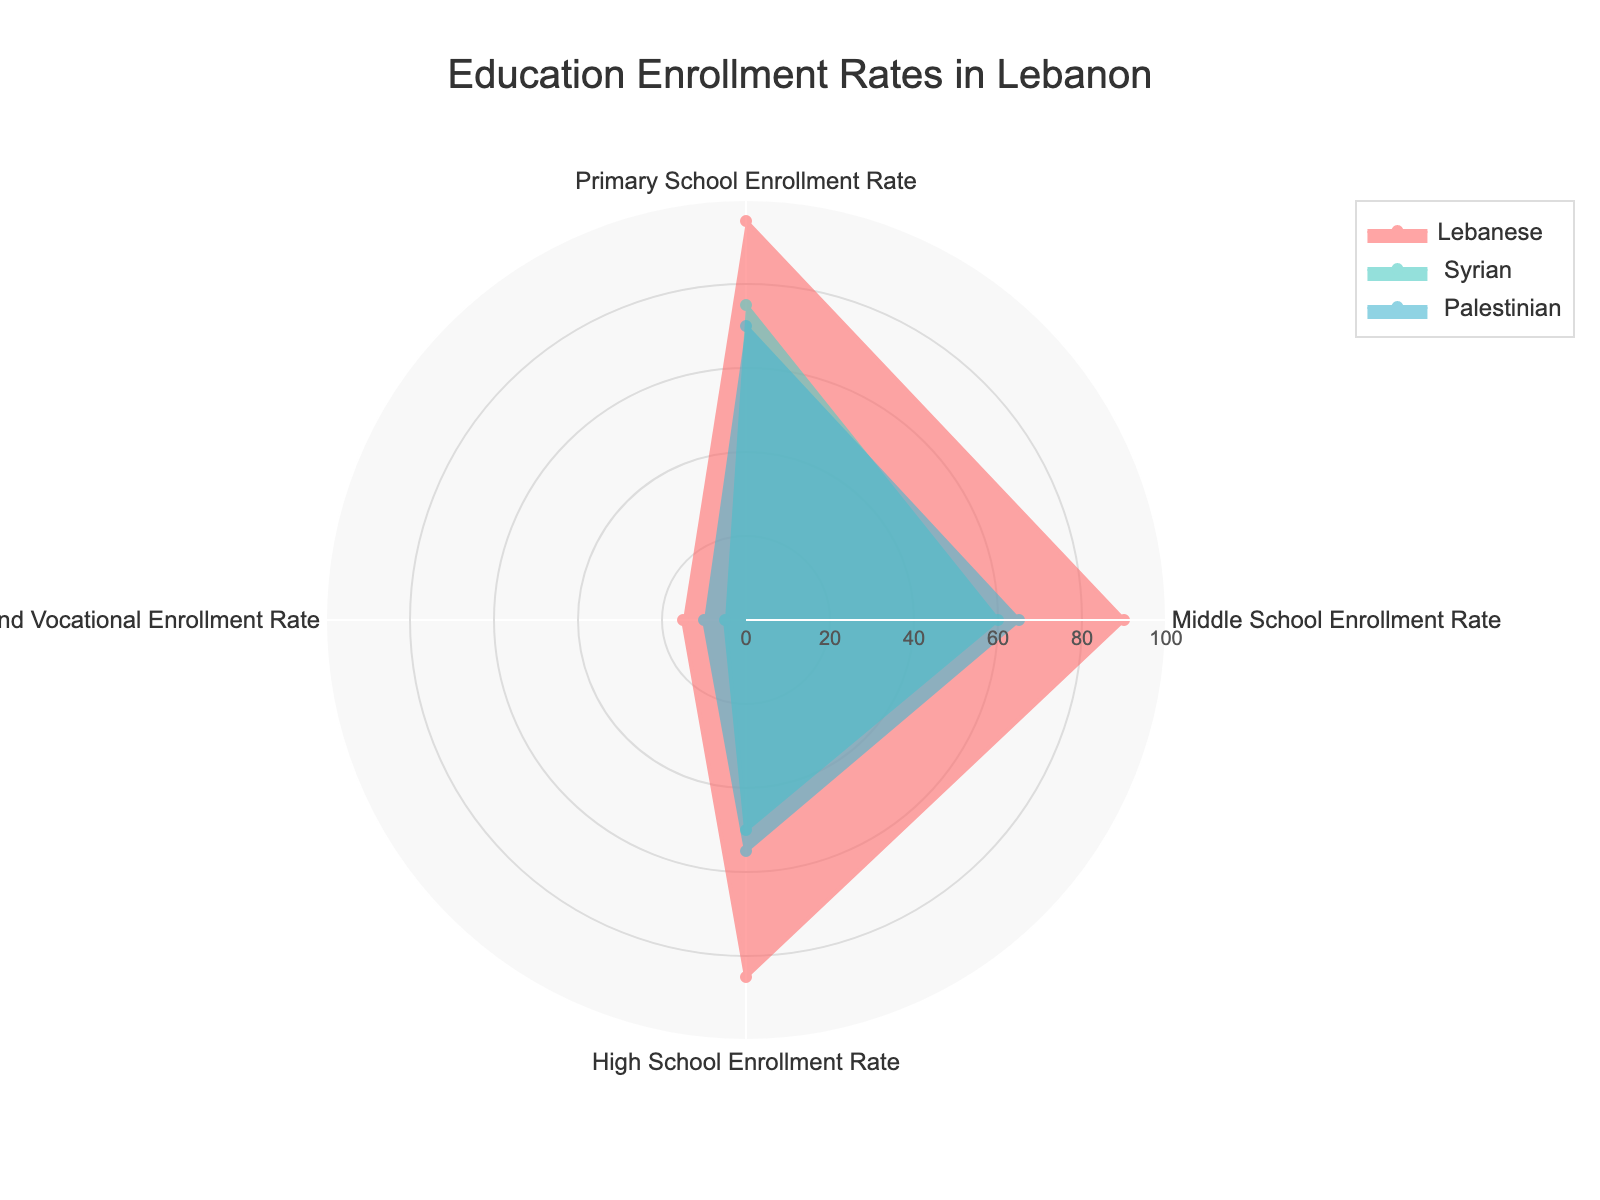what is the title of the figure? The title is usually located at the top of the figure. In this case, it is specified in the layout update of the plot.
Answer: Education Enrollment Rates in Lebanon Which group shows the highest Primary School Enrollment Rate? By observing the plot, identify the group with the highest point along the Primary School Enrollment Rate axis. The Lebanese group has the highest point at 95%.
Answer: Lebanese What is the enrollment rate for the Syrian group in Technical and Vocational education? Find the Syrian group's point along the Technical and Vocational axis. The plot shows this value at 5%.
Answer: 5% Which two groups have the closest High School Enrollment Rates? Compare the High School Enrollment Rates for all groups. The Syrian group has 50% and the Palestinian group has 55%, making them the closest.
Answer: Syrian and Palestinian What is the difference in Middle School Enrollment Rate between Lebanese and Palestinian children? Subtract the Palestinian rate from the Lebanese rate for Middle School. 90% - 65% = 25%.
Answer: 25% Which category shows the lowest enrollment rate for the Lebanese group? Look for the category with the smallest point for the Lebanese group. Technical and Vocational education has the lowest rate at 15%.
Answer: Technical and Vocational Enrollment Rate How many categories are compared in the figure? Count the number of distinct axes labeled with enrollment categories in the radar chart. There are four categories visible.
Answer: 4 What is the average High School Enrollment Rate across all three groups? Sum the High School Enrollment Rates and divide by the number of groups: (85% + 50% + 55%) / 3 = 63.33%.
Answer: 63.33% Which group shows the largest drop from Primary to High School Enrollment Rates? Calculate the difference between Primary and High School rates for each group. Lebanese: 95% to 85% (10% drop), Syrian: 75% to 50% (25% drop), Palestinian: 70% to 55% (15% drop). The Syrian group shows the largest drop.
Answer: Syrian In which category do the Palestinian children have a higher enrollment rate than the Syrian children? Compare each category's rates for Palestinian and Syrian children. In Middle School and High School, Palestinian children have higher rates (65% vs 60% and 55% vs 50%).
Answer: Middle School and High School 